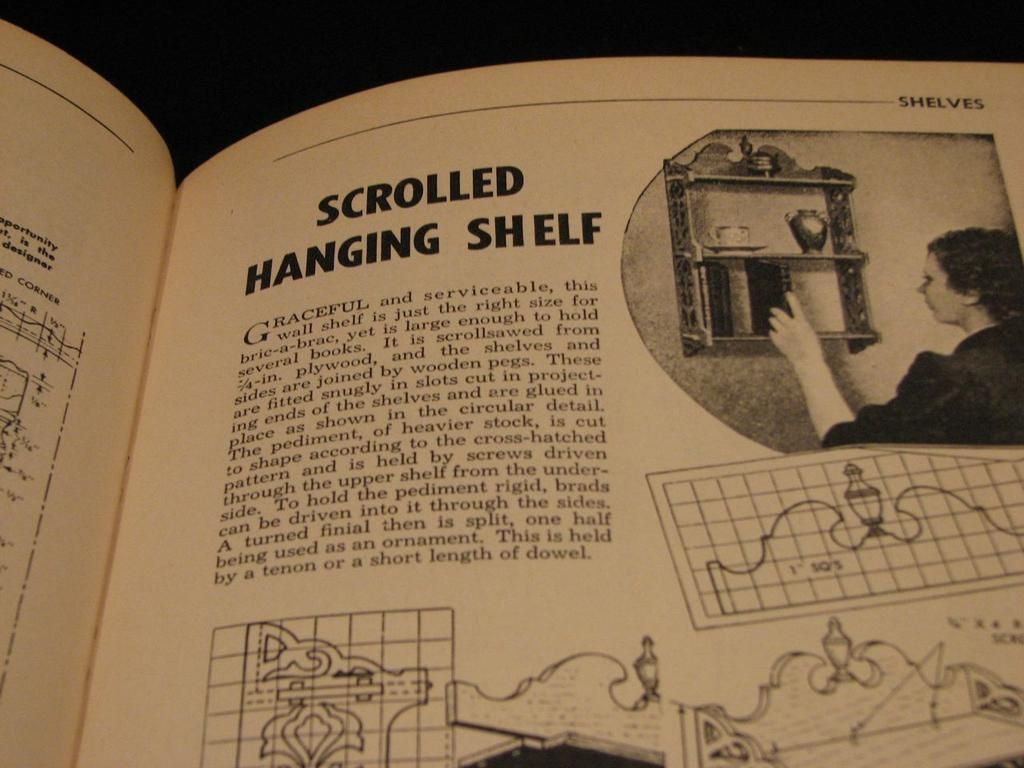Provide a one-sentence caption for the provided image. a BOOK ABOUT SCROLLED HANGING SHELF IS OPEN TO A PAGE WITH A WOMEN PUTTING SOMETHING ON A SHELF. 